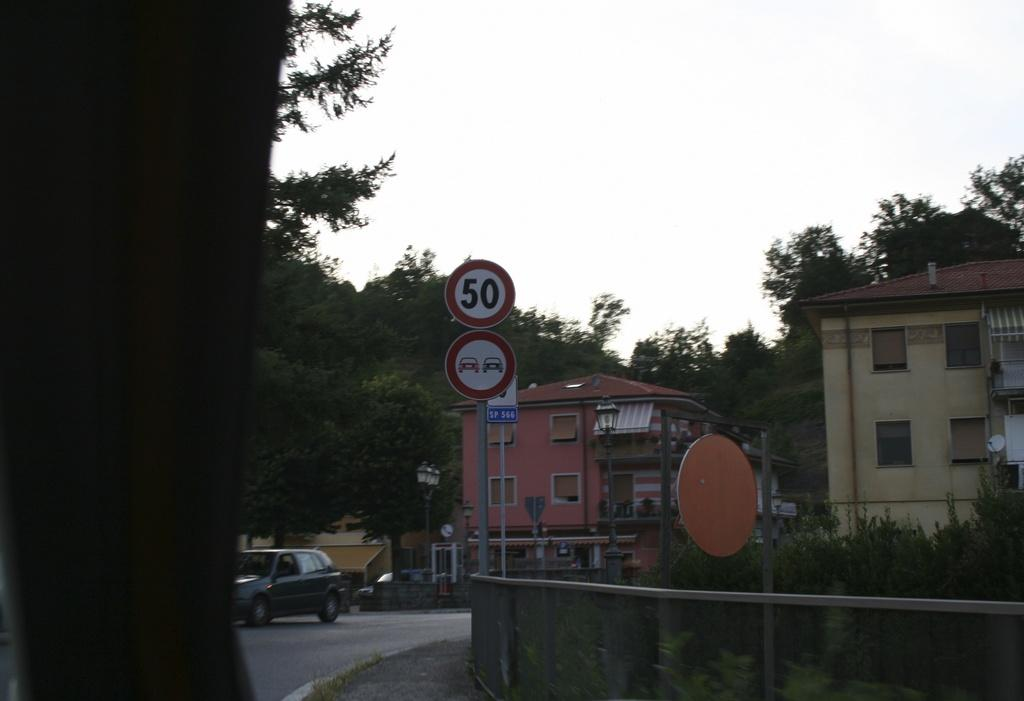What type of structures can be seen in the image? There are buildings in the image. What other natural elements are present in the image? There are trees in the image. What mode of transportation can be seen on the road in the image? There is a car on the road in the image. What note is being played by the tree in the image? There is no note being played by the tree in the image, as trees do not have the ability to play music. 